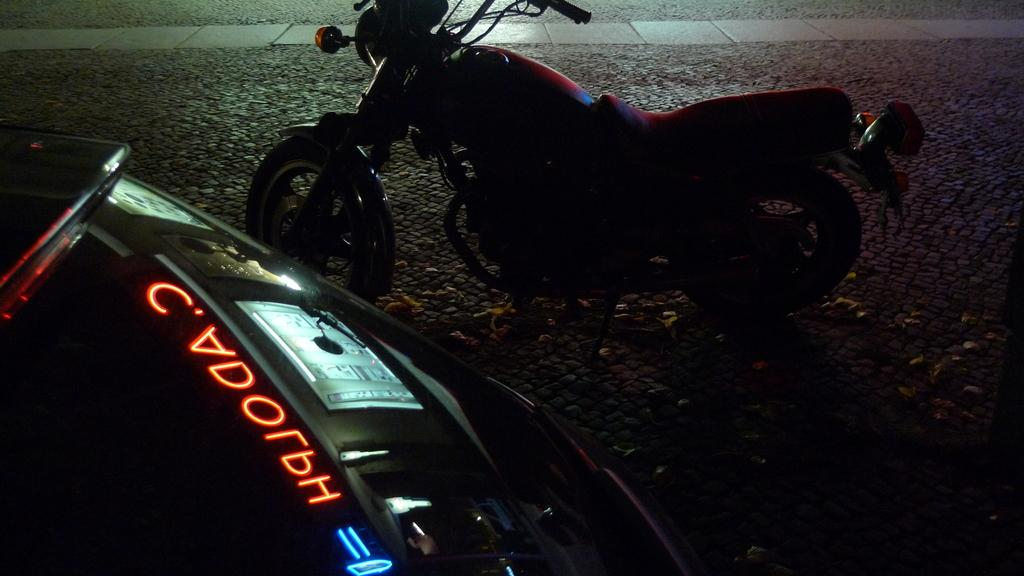What is the main subject of the image? There is a vehicle in the image. What can be seen in the background of the image? There is a floor visible in the background of the image, along with other objects. Are there any other vehicles in the image? Yes, there is another vehicle on the left side of the image. How does the judge beginner their day in the image? There is no judge or beginner present in the image; it features vehicles and a background. 